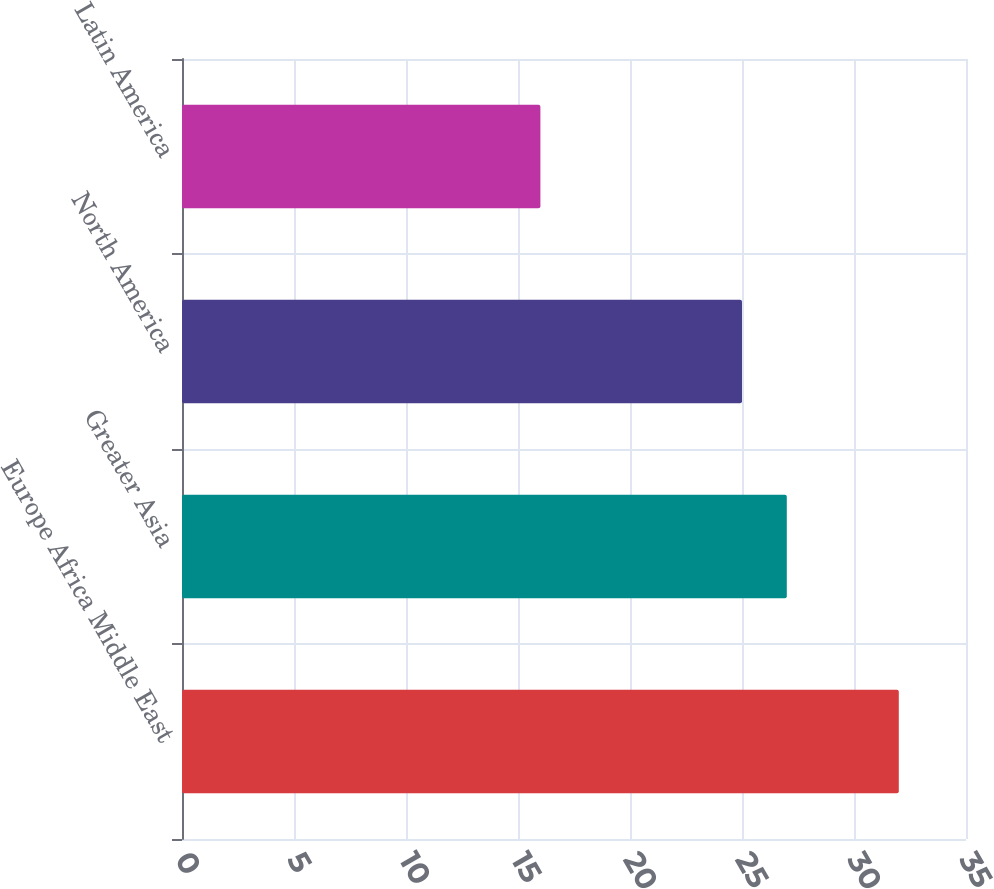<chart> <loc_0><loc_0><loc_500><loc_500><bar_chart><fcel>Europe Africa Middle East<fcel>Greater Asia<fcel>North America<fcel>Latin America<nl><fcel>32<fcel>27<fcel>25<fcel>16<nl></chart> 